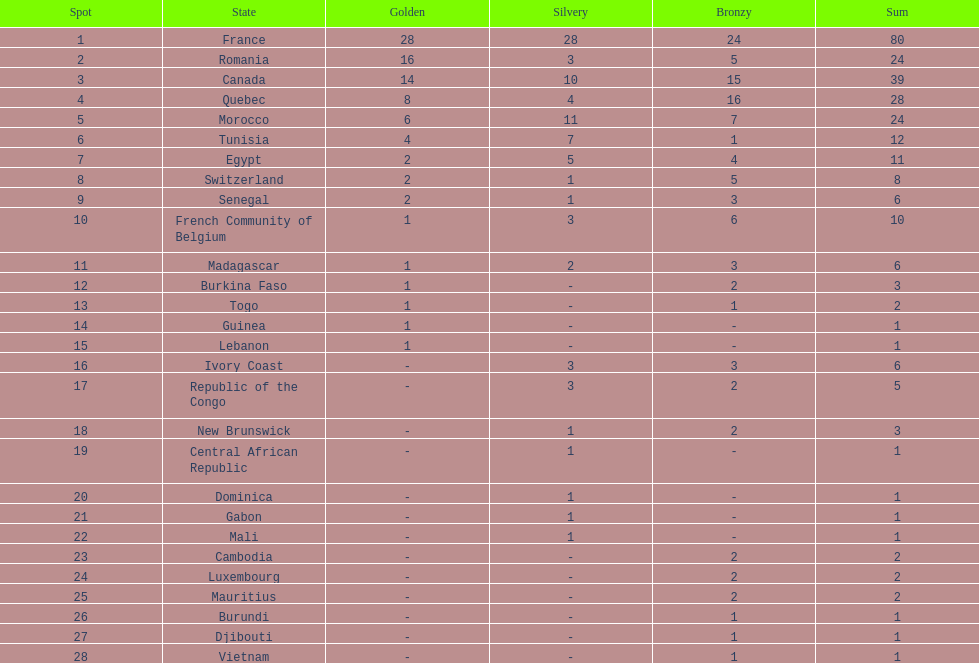What is the difference between france's and egypt's silver medals? 23. 